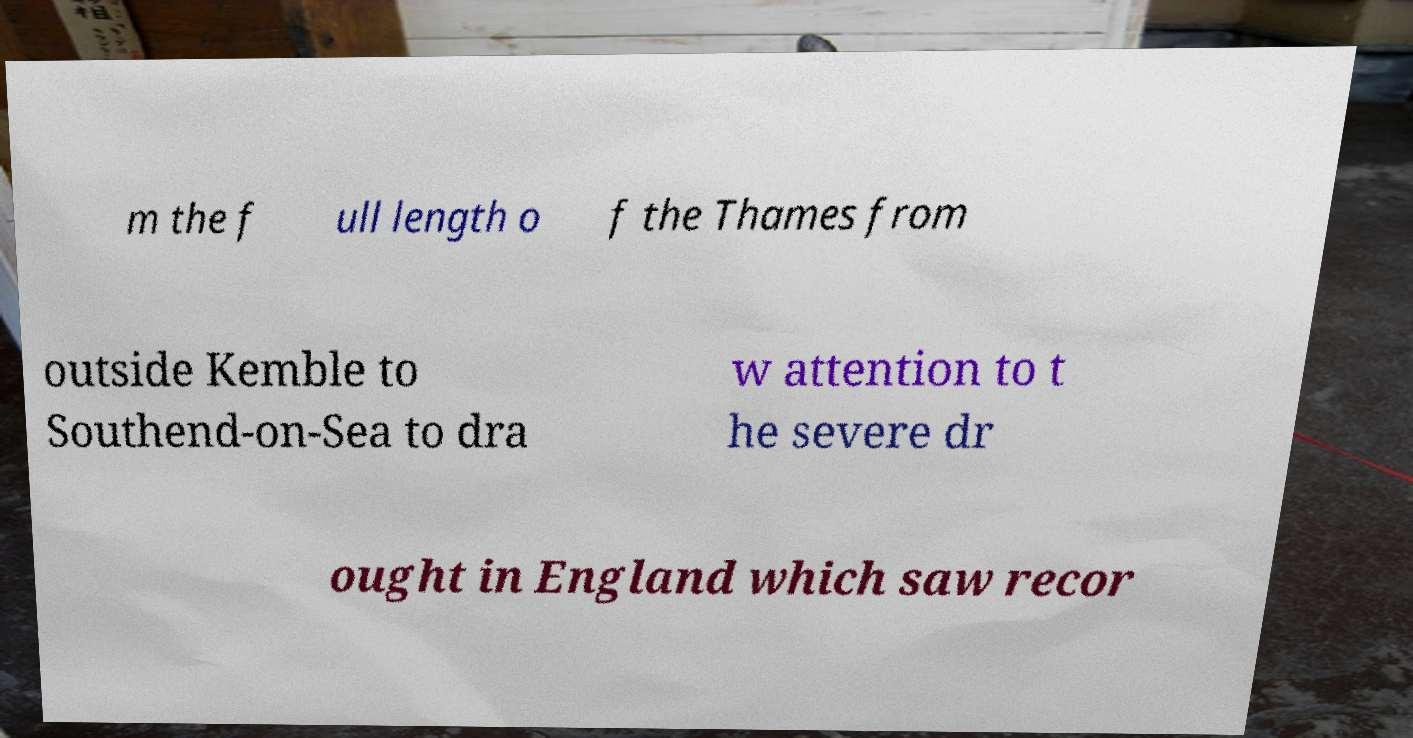Can you read and provide the text displayed in the image?This photo seems to have some interesting text. Can you extract and type it out for me? m the f ull length o f the Thames from outside Kemble to Southend-on-Sea to dra w attention to t he severe dr ought in England which saw recor 